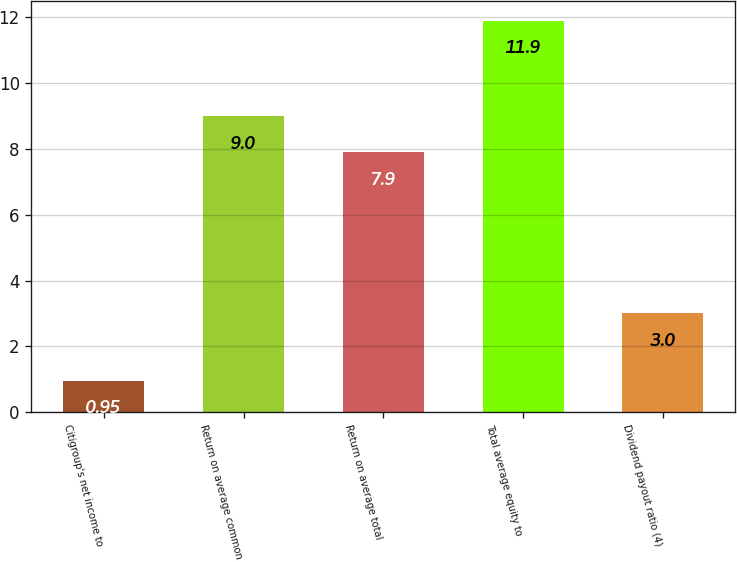Convert chart to OTSL. <chart><loc_0><loc_0><loc_500><loc_500><bar_chart><fcel>Citigroup's net income to<fcel>Return on average common<fcel>Return on average total<fcel>Total average equity to<fcel>Dividend payout ratio (4)<nl><fcel>0.95<fcel>9<fcel>7.9<fcel>11.9<fcel>3<nl></chart> 